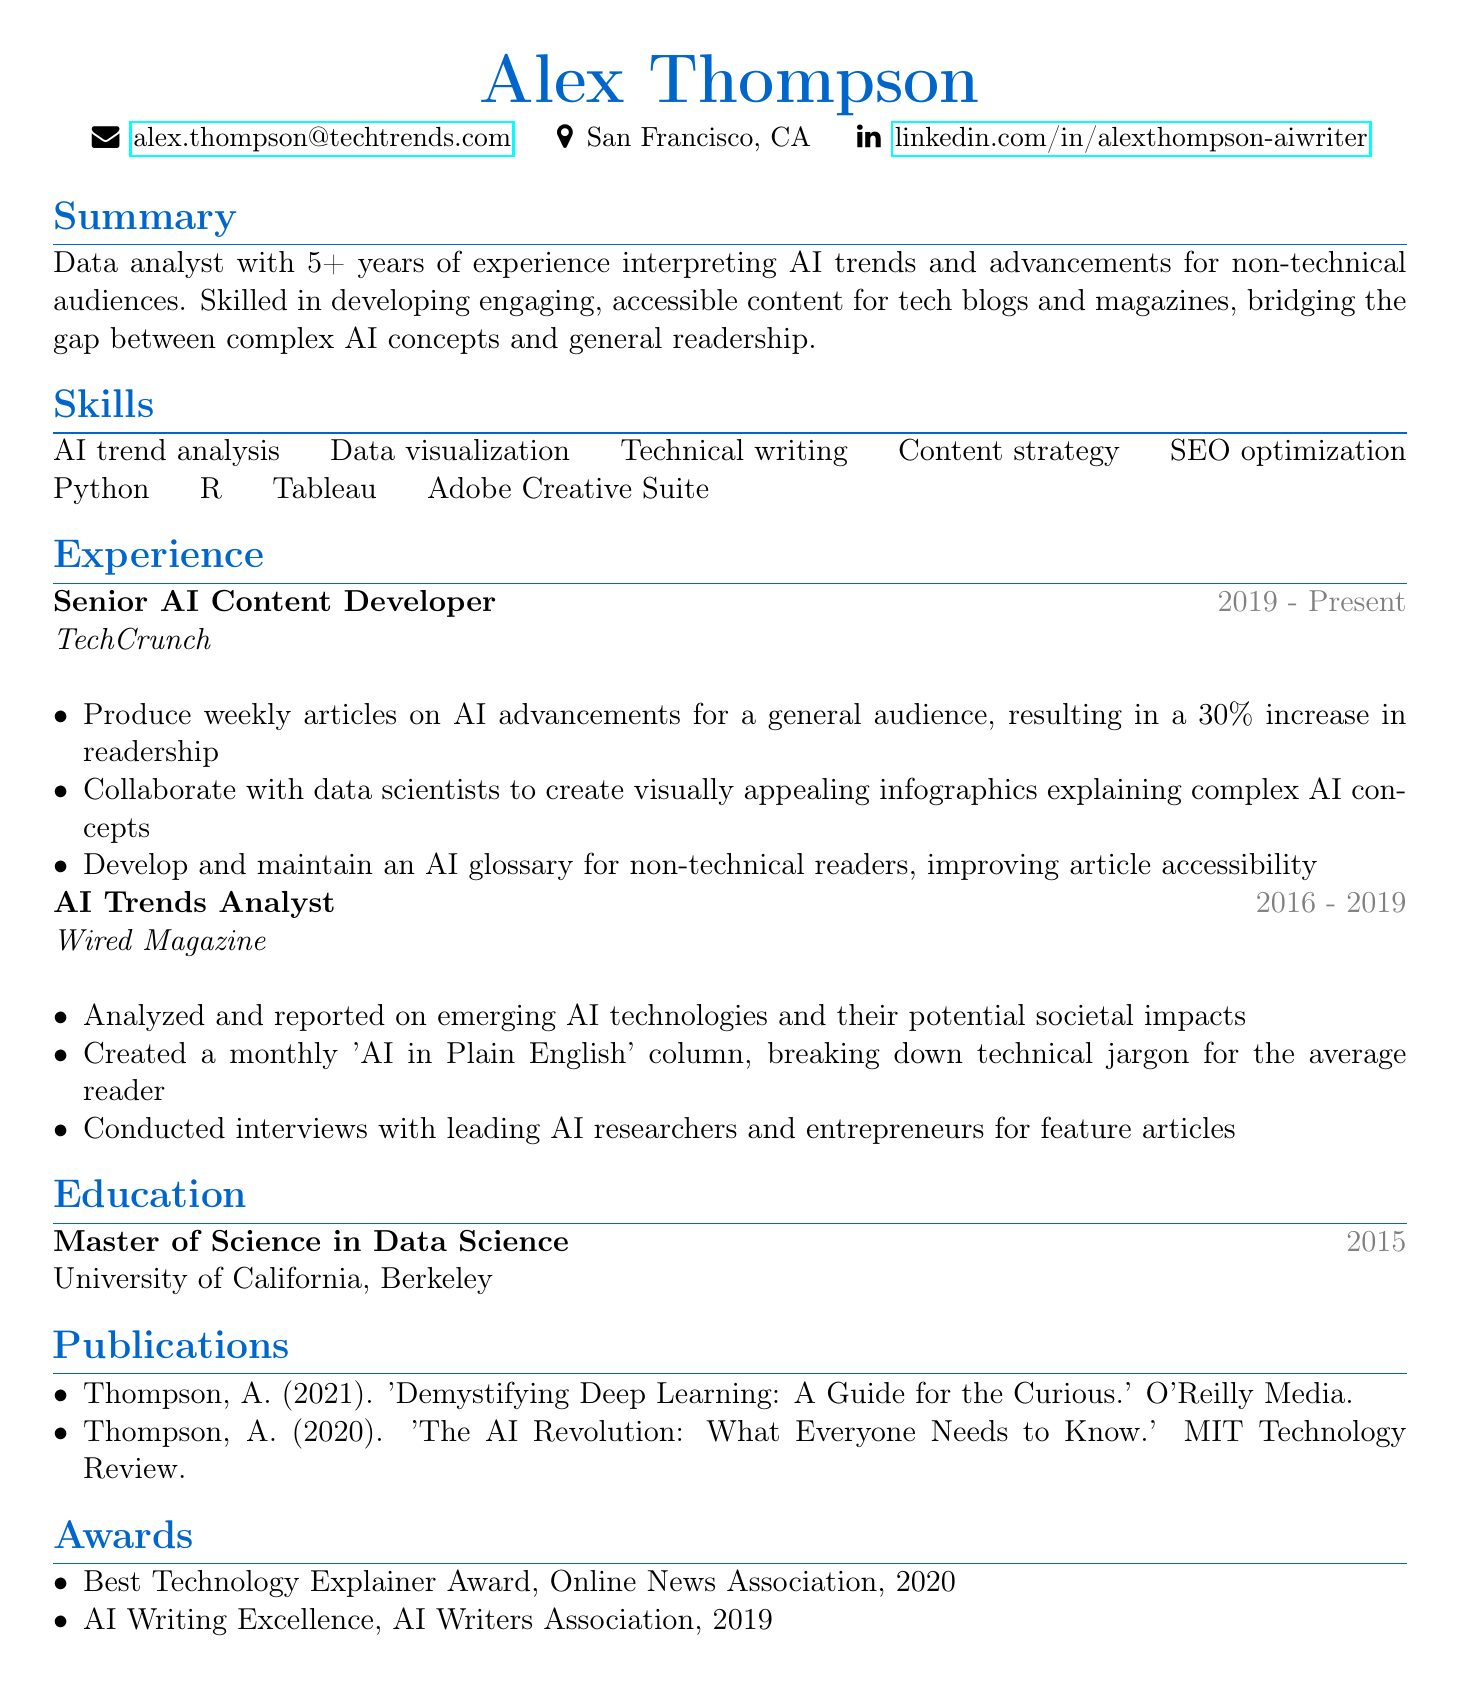what is the current job title of Alex Thompson? Alex Thompson is currently employed as a Senior AI Content Developer, as listed in the experience section.
Answer: Senior AI Content Developer which company did Alex Thompson work for between 2016 and 2019? The document states that Alex Thompson worked for Wired Magazine during that period.
Answer: Wired Magazine how many years of experience does Alex Thompson have? The summary indicates that Alex Thompson has over 5 years of experience in the field.
Answer: 5+ what is one of Alex Thompson's key skills? The skills section lists several skills, and one key skill is AI trend analysis.
Answer: AI trend analysis in which year did Alex Thompson complete their Master of Science in Data Science? The education section specifies that Alex Thompson graduated in 2015.
Answer: 2015 what was a significant achievement during Alex Thompson's tenure at TechCrunch? The responsibilities under TechCrunch note a 30% increase in readership as a significant achievement.
Answer: 30% increase in readership which award did Alex Thompson receive in 2020? The awards section mentions that Alex Thompson received the Best Technology Explainer Award in 2020.
Answer: Best Technology Explainer Award what was the focus of the monthly column created by Alex Thompson at Wired Magazine? The column was titled 'AI in Plain English', focusing on breaking down technical jargon.
Answer: 'AI in Plain English' column name a publication authored by Alex Thompson. The publications section lists articles, one of which is 'Demystifying Deep Learning: A Guide for the Curious.'
Answer: 'Demystifying Deep Learning: A Guide for the Curious.' 